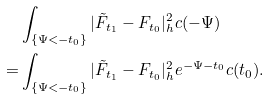Convert formula to latex. <formula><loc_0><loc_0><loc_500><loc_500>& \int _ { \{ \Psi < - t _ { 0 } \} } | \tilde { F } _ { t _ { 1 } } - F _ { t _ { 0 } } | ^ { 2 } _ { h } c ( - \Psi ) \\ = & \int _ { \{ \Psi < - t _ { 0 } \} } | \tilde { F } _ { t _ { 1 } } - F _ { t _ { 0 } } | ^ { 2 } _ { h } e ^ { - \Psi - t _ { 0 } } c ( t _ { 0 } ) . \\</formula> 